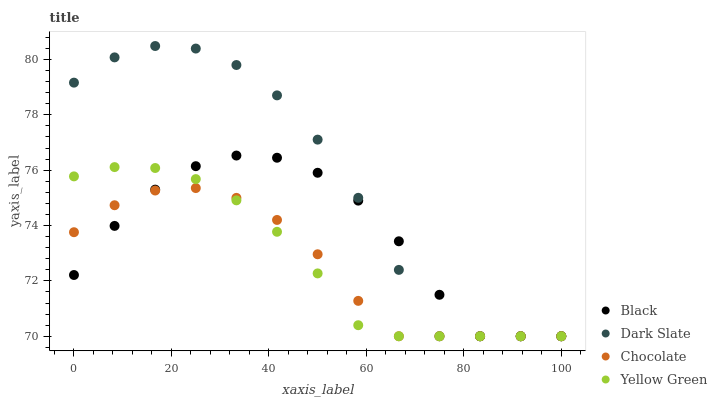Does Chocolate have the minimum area under the curve?
Answer yes or no. Yes. Does Dark Slate have the maximum area under the curve?
Answer yes or no. Yes. Does Black have the minimum area under the curve?
Answer yes or no. No. Does Black have the maximum area under the curve?
Answer yes or no. No. Is Yellow Green the smoothest?
Answer yes or no. Yes. Is Dark Slate the roughest?
Answer yes or no. Yes. Is Black the smoothest?
Answer yes or no. No. Is Black the roughest?
Answer yes or no. No. Does Dark Slate have the lowest value?
Answer yes or no. Yes. Does Dark Slate have the highest value?
Answer yes or no. Yes. Does Black have the highest value?
Answer yes or no. No. Does Yellow Green intersect Dark Slate?
Answer yes or no. Yes. Is Yellow Green less than Dark Slate?
Answer yes or no. No. Is Yellow Green greater than Dark Slate?
Answer yes or no. No. 